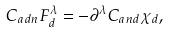<formula> <loc_0><loc_0><loc_500><loc_500>C _ { a d n } F _ { d } ^ { \lambda } = - \partial ^ { \lambda } C _ { a n d } \chi _ { d } ,</formula> 